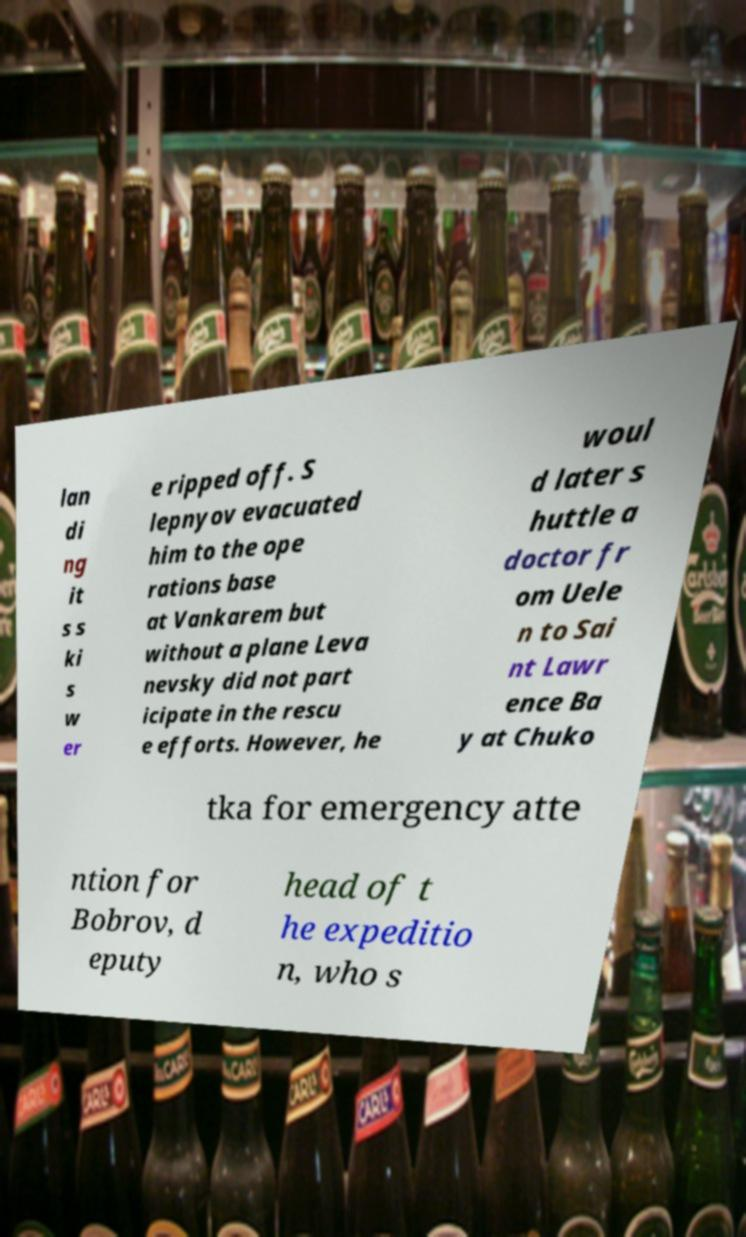Please identify and transcribe the text found in this image. lan di ng it s s ki s w er e ripped off. S lepnyov evacuated him to the ope rations base at Vankarem but without a plane Leva nevsky did not part icipate in the rescu e efforts. However, he woul d later s huttle a doctor fr om Uele n to Sai nt Lawr ence Ba y at Chuko tka for emergency atte ntion for Bobrov, d eputy head of t he expeditio n, who s 